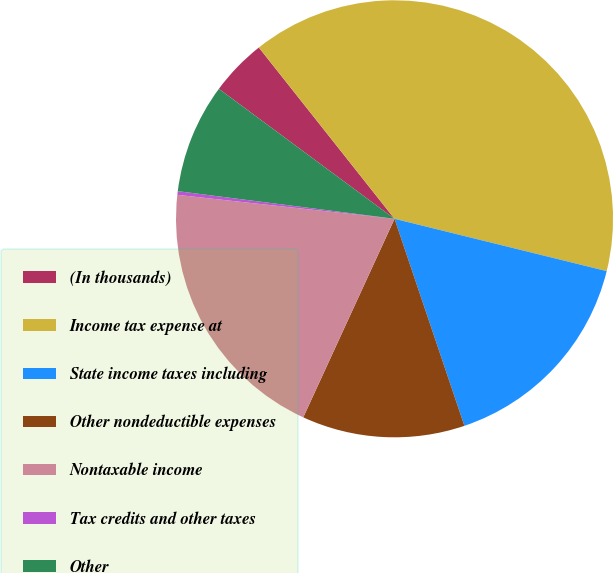Convert chart. <chart><loc_0><loc_0><loc_500><loc_500><pie_chart><fcel>(In thousands)<fcel>Income tax expense at<fcel>State income taxes including<fcel>Other nondeductible expenses<fcel>Nontaxable income<fcel>Tax credits and other taxes<fcel>Other<nl><fcel>4.2%<fcel>39.51%<fcel>15.97%<fcel>12.04%<fcel>19.89%<fcel>0.27%<fcel>8.12%<nl></chart> 